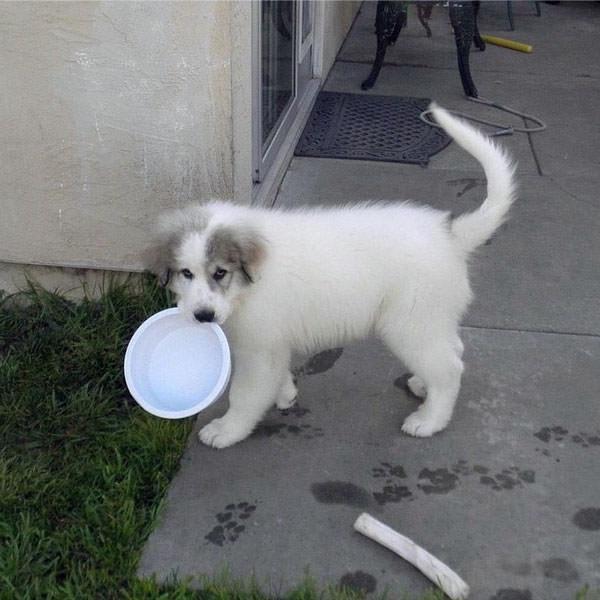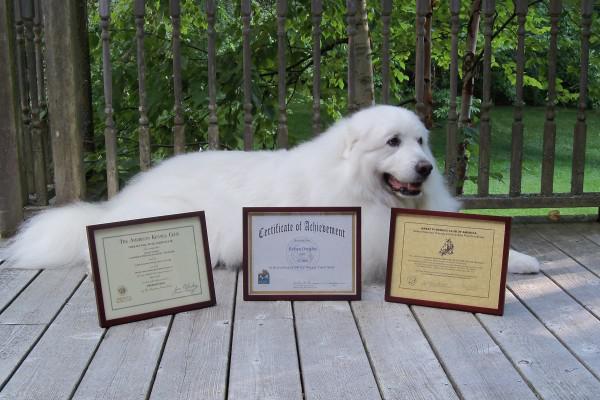The first image is the image on the left, the second image is the image on the right. Evaluate the accuracy of this statement regarding the images: "An image contains a large white dog laying down next to framed certificates.". Is it true? Answer yes or no. Yes. The first image is the image on the left, the second image is the image on the right. For the images shown, is this caption "In one of the images, a white dog is laying down behind at least three framed documents." true? Answer yes or no. Yes. 